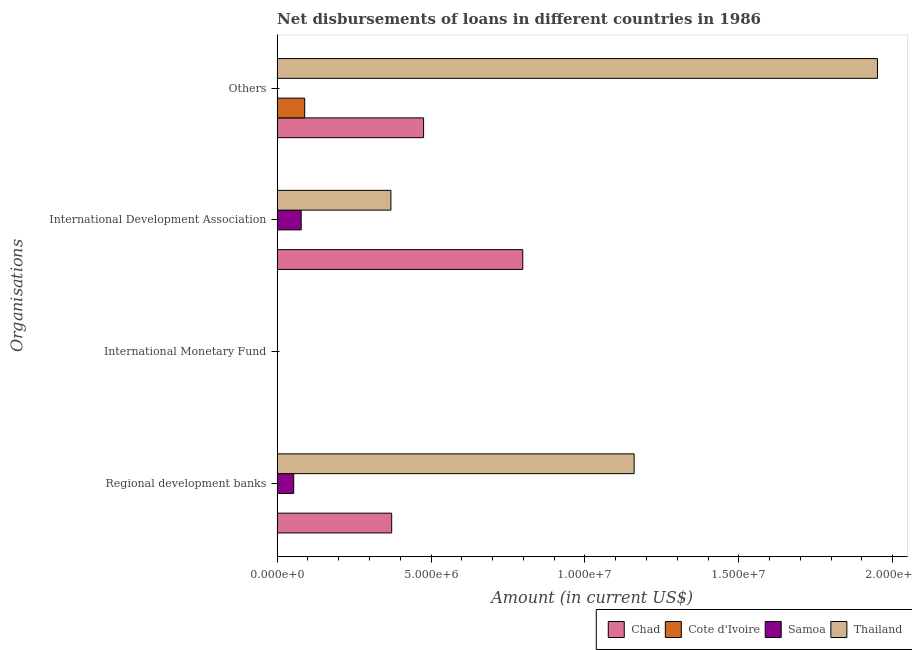How many different coloured bars are there?
Provide a short and direct response. 4. Are the number of bars per tick equal to the number of legend labels?
Offer a very short reply. No. How many bars are there on the 4th tick from the top?
Provide a short and direct response. 3. How many bars are there on the 2nd tick from the bottom?
Offer a very short reply. 0. What is the label of the 2nd group of bars from the top?
Provide a succinct answer. International Development Association. What is the amount of loan disimbursed by regional development banks in Samoa?
Your response must be concise. 5.39e+05. Across all countries, what is the maximum amount of loan disimbursed by other organisations?
Your response must be concise. 1.95e+07. In which country was the amount of loan disimbursed by international development association maximum?
Provide a succinct answer. Chad. What is the total amount of loan disimbursed by international development association in the graph?
Give a very brief answer. 1.25e+07. What is the difference between the amount of loan disimbursed by regional development banks in Thailand and that in Samoa?
Your answer should be compact. 1.11e+07. What is the difference between the amount of loan disimbursed by international monetary fund in Thailand and the amount of loan disimbursed by international development association in Samoa?
Give a very brief answer. -7.82e+05. What is the average amount of loan disimbursed by international monetary fund per country?
Offer a very short reply. 0. What is the difference between the amount of loan disimbursed by other organisations and amount of loan disimbursed by international development association in Thailand?
Provide a succinct answer. 1.58e+07. What is the ratio of the amount of loan disimbursed by international development association in Samoa to that in Chad?
Ensure brevity in your answer.  0.1. What is the difference between the highest and the second highest amount of loan disimbursed by regional development banks?
Provide a succinct answer. 7.88e+06. What is the difference between the highest and the lowest amount of loan disimbursed by international development association?
Ensure brevity in your answer.  7.98e+06. Is the sum of the amount of loan disimbursed by other organisations in Thailand and Cote d'Ivoire greater than the maximum amount of loan disimbursed by international development association across all countries?
Your answer should be very brief. Yes. How many bars are there?
Give a very brief answer. 9. Are all the bars in the graph horizontal?
Offer a very short reply. Yes. How many countries are there in the graph?
Provide a short and direct response. 4. Are the values on the major ticks of X-axis written in scientific E-notation?
Your answer should be very brief. Yes. Where does the legend appear in the graph?
Your answer should be very brief. Bottom right. How many legend labels are there?
Provide a short and direct response. 4. What is the title of the graph?
Provide a short and direct response. Net disbursements of loans in different countries in 1986. What is the label or title of the X-axis?
Keep it short and to the point. Amount (in current US$). What is the label or title of the Y-axis?
Give a very brief answer. Organisations. What is the Amount (in current US$) in Chad in Regional development banks?
Ensure brevity in your answer.  3.72e+06. What is the Amount (in current US$) in Cote d'Ivoire in Regional development banks?
Make the answer very short. 0. What is the Amount (in current US$) in Samoa in Regional development banks?
Provide a succinct answer. 5.39e+05. What is the Amount (in current US$) of Thailand in Regional development banks?
Your response must be concise. 1.16e+07. What is the Amount (in current US$) of Thailand in International Monetary Fund?
Your answer should be very brief. 0. What is the Amount (in current US$) in Chad in International Development Association?
Give a very brief answer. 7.98e+06. What is the Amount (in current US$) of Cote d'Ivoire in International Development Association?
Ensure brevity in your answer.  0. What is the Amount (in current US$) in Samoa in International Development Association?
Provide a succinct answer. 7.82e+05. What is the Amount (in current US$) in Thailand in International Development Association?
Provide a succinct answer. 3.70e+06. What is the Amount (in current US$) of Chad in Others?
Provide a short and direct response. 4.76e+06. What is the Amount (in current US$) in Cote d'Ivoire in Others?
Your response must be concise. 8.96e+05. What is the Amount (in current US$) of Thailand in Others?
Your response must be concise. 1.95e+07. Across all Organisations, what is the maximum Amount (in current US$) in Chad?
Offer a very short reply. 7.98e+06. Across all Organisations, what is the maximum Amount (in current US$) of Cote d'Ivoire?
Offer a very short reply. 8.96e+05. Across all Organisations, what is the maximum Amount (in current US$) of Samoa?
Your answer should be compact. 7.82e+05. Across all Organisations, what is the maximum Amount (in current US$) in Thailand?
Your response must be concise. 1.95e+07. Across all Organisations, what is the minimum Amount (in current US$) in Chad?
Provide a short and direct response. 0. Across all Organisations, what is the minimum Amount (in current US$) of Cote d'Ivoire?
Provide a succinct answer. 0. Across all Organisations, what is the minimum Amount (in current US$) of Samoa?
Your answer should be very brief. 0. What is the total Amount (in current US$) in Chad in the graph?
Offer a terse response. 1.65e+07. What is the total Amount (in current US$) in Cote d'Ivoire in the graph?
Offer a very short reply. 8.96e+05. What is the total Amount (in current US$) in Samoa in the graph?
Offer a terse response. 1.32e+06. What is the total Amount (in current US$) in Thailand in the graph?
Your response must be concise. 3.48e+07. What is the difference between the Amount (in current US$) in Chad in Regional development banks and that in International Development Association?
Offer a very short reply. -4.26e+06. What is the difference between the Amount (in current US$) of Samoa in Regional development banks and that in International Development Association?
Provide a short and direct response. -2.43e+05. What is the difference between the Amount (in current US$) of Thailand in Regional development banks and that in International Development Association?
Ensure brevity in your answer.  7.90e+06. What is the difference between the Amount (in current US$) of Chad in Regional development banks and that in Others?
Keep it short and to the point. -1.04e+06. What is the difference between the Amount (in current US$) of Thailand in Regional development banks and that in Others?
Provide a short and direct response. -7.91e+06. What is the difference between the Amount (in current US$) in Chad in International Development Association and that in Others?
Ensure brevity in your answer.  3.22e+06. What is the difference between the Amount (in current US$) in Thailand in International Development Association and that in Others?
Your answer should be compact. -1.58e+07. What is the difference between the Amount (in current US$) in Chad in Regional development banks and the Amount (in current US$) in Samoa in International Development Association?
Your answer should be very brief. 2.94e+06. What is the difference between the Amount (in current US$) of Chad in Regional development banks and the Amount (in current US$) of Thailand in International Development Association?
Offer a very short reply. 2.50e+04. What is the difference between the Amount (in current US$) of Samoa in Regional development banks and the Amount (in current US$) of Thailand in International Development Association?
Offer a very short reply. -3.16e+06. What is the difference between the Amount (in current US$) in Chad in Regional development banks and the Amount (in current US$) in Cote d'Ivoire in Others?
Your answer should be compact. 2.83e+06. What is the difference between the Amount (in current US$) of Chad in Regional development banks and the Amount (in current US$) of Thailand in Others?
Provide a succinct answer. -1.58e+07. What is the difference between the Amount (in current US$) in Samoa in Regional development banks and the Amount (in current US$) in Thailand in Others?
Your answer should be very brief. -1.90e+07. What is the difference between the Amount (in current US$) of Chad in International Development Association and the Amount (in current US$) of Cote d'Ivoire in Others?
Your answer should be compact. 7.08e+06. What is the difference between the Amount (in current US$) of Chad in International Development Association and the Amount (in current US$) of Thailand in Others?
Offer a very short reply. -1.15e+07. What is the difference between the Amount (in current US$) of Samoa in International Development Association and the Amount (in current US$) of Thailand in Others?
Provide a succinct answer. -1.87e+07. What is the average Amount (in current US$) in Chad per Organisations?
Provide a succinct answer. 4.12e+06. What is the average Amount (in current US$) of Cote d'Ivoire per Organisations?
Keep it short and to the point. 2.24e+05. What is the average Amount (in current US$) of Samoa per Organisations?
Offer a very short reply. 3.30e+05. What is the average Amount (in current US$) in Thailand per Organisations?
Provide a short and direct response. 8.70e+06. What is the difference between the Amount (in current US$) of Chad and Amount (in current US$) of Samoa in Regional development banks?
Ensure brevity in your answer.  3.18e+06. What is the difference between the Amount (in current US$) of Chad and Amount (in current US$) of Thailand in Regional development banks?
Offer a very short reply. -7.88e+06. What is the difference between the Amount (in current US$) in Samoa and Amount (in current US$) in Thailand in Regional development banks?
Give a very brief answer. -1.11e+07. What is the difference between the Amount (in current US$) in Chad and Amount (in current US$) in Samoa in International Development Association?
Offer a very short reply. 7.20e+06. What is the difference between the Amount (in current US$) in Chad and Amount (in current US$) in Thailand in International Development Association?
Give a very brief answer. 4.28e+06. What is the difference between the Amount (in current US$) of Samoa and Amount (in current US$) of Thailand in International Development Association?
Provide a succinct answer. -2.92e+06. What is the difference between the Amount (in current US$) in Chad and Amount (in current US$) in Cote d'Ivoire in Others?
Your answer should be very brief. 3.86e+06. What is the difference between the Amount (in current US$) in Chad and Amount (in current US$) in Thailand in Others?
Your answer should be very brief. -1.47e+07. What is the difference between the Amount (in current US$) in Cote d'Ivoire and Amount (in current US$) in Thailand in Others?
Make the answer very short. -1.86e+07. What is the ratio of the Amount (in current US$) in Chad in Regional development banks to that in International Development Association?
Offer a terse response. 0.47. What is the ratio of the Amount (in current US$) in Samoa in Regional development banks to that in International Development Association?
Your answer should be very brief. 0.69. What is the ratio of the Amount (in current US$) in Thailand in Regional development banks to that in International Development Association?
Provide a short and direct response. 3.14. What is the ratio of the Amount (in current US$) of Chad in Regional development banks to that in Others?
Your answer should be very brief. 0.78. What is the ratio of the Amount (in current US$) in Thailand in Regional development banks to that in Others?
Offer a very short reply. 0.59. What is the ratio of the Amount (in current US$) in Chad in International Development Association to that in Others?
Your answer should be very brief. 1.68. What is the ratio of the Amount (in current US$) of Thailand in International Development Association to that in Others?
Ensure brevity in your answer.  0.19. What is the difference between the highest and the second highest Amount (in current US$) in Chad?
Make the answer very short. 3.22e+06. What is the difference between the highest and the second highest Amount (in current US$) of Thailand?
Offer a terse response. 7.91e+06. What is the difference between the highest and the lowest Amount (in current US$) in Chad?
Offer a terse response. 7.98e+06. What is the difference between the highest and the lowest Amount (in current US$) in Cote d'Ivoire?
Make the answer very short. 8.96e+05. What is the difference between the highest and the lowest Amount (in current US$) of Samoa?
Offer a terse response. 7.82e+05. What is the difference between the highest and the lowest Amount (in current US$) of Thailand?
Offer a terse response. 1.95e+07. 